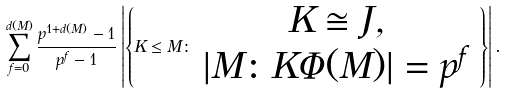Convert formula to latex. <formula><loc_0><loc_0><loc_500><loc_500>\sum _ { f = 0 } ^ { d ( M ) } \frac { p ^ { 1 + d ( M ) } - 1 } { p ^ { f } - 1 } \left | \left \{ K \leq M \colon \begin{array} { c } K \cong J , \\ | M \colon K \Phi ( M ) | = p ^ { f } \end{array} \right \} \right | .</formula> 